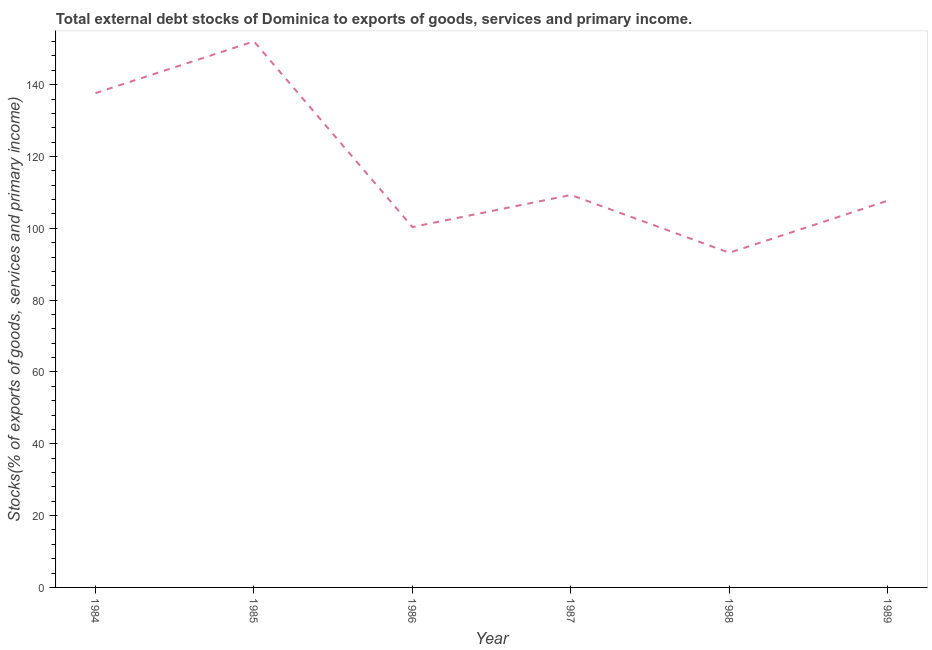What is the external debt stocks in 1989?
Ensure brevity in your answer.  107.7. Across all years, what is the maximum external debt stocks?
Keep it short and to the point. 152.04. Across all years, what is the minimum external debt stocks?
Provide a succinct answer. 93.19. In which year was the external debt stocks maximum?
Make the answer very short. 1985. What is the sum of the external debt stocks?
Make the answer very short. 700.21. What is the difference between the external debt stocks in 1984 and 1989?
Your response must be concise. 29.94. What is the average external debt stocks per year?
Make the answer very short. 116.7. What is the median external debt stocks?
Provide a short and direct response. 108.49. Do a majority of the years between 1986 and 1985 (inclusive) have external debt stocks greater than 56 %?
Offer a terse response. No. What is the ratio of the external debt stocks in 1984 to that in 1986?
Give a very brief answer. 1.37. What is the difference between the highest and the second highest external debt stocks?
Your answer should be compact. 14.4. Is the sum of the external debt stocks in 1987 and 1988 greater than the maximum external debt stocks across all years?
Make the answer very short. Yes. What is the difference between the highest and the lowest external debt stocks?
Give a very brief answer. 58.86. Does the external debt stocks monotonically increase over the years?
Make the answer very short. No. How many lines are there?
Your answer should be compact. 1. What is the difference between two consecutive major ticks on the Y-axis?
Offer a terse response. 20. Are the values on the major ticks of Y-axis written in scientific E-notation?
Your answer should be compact. No. What is the title of the graph?
Offer a very short reply. Total external debt stocks of Dominica to exports of goods, services and primary income. What is the label or title of the Y-axis?
Provide a short and direct response. Stocks(% of exports of goods, services and primary income). What is the Stocks(% of exports of goods, services and primary income) of 1984?
Provide a short and direct response. 137.64. What is the Stocks(% of exports of goods, services and primary income) of 1985?
Give a very brief answer. 152.04. What is the Stocks(% of exports of goods, services and primary income) of 1986?
Keep it short and to the point. 100.35. What is the Stocks(% of exports of goods, services and primary income) in 1987?
Your answer should be very brief. 109.28. What is the Stocks(% of exports of goods, services and primary income) of 1988?
Provide a short and direct response. 93.19. What is the Stocks(% of exports of goods, services and primary income) in 1989?
Your answer should be very brief. 107.7. What is the difference between the Stocks(% of exports of goods, services and primary income) in 1984 and 1985?
Provide a short and direct response. -14.4. What is the difference between the Stocks(% of exports of goods, services and primary income) in 1984 and 1986?
Provide a short and direct response. 37.29. What is the difference between the Stocks(% of exports of goods, services and primary income) in 1984 and 1987?
Ensure brevity in your answer.  28.36. What is the difference between the Stocks(% of exports of goods, services and primary income) in 1984 and 1988?
Provide a succinct answer. 44.46. What is the difference between the Stocks(% of exports of goods, services and primary income) in 1984 and 1989?
Your answer should be very brief. 29.94. What is the difference between the Stocks(% of exports of goods, services and primary income) in 1985 and 1986?
Make the answer very short. 51.69. What is the difference between the Stocks(% of exports of goods, services and primary income) in 1985 and 1987?
Keep it short and to the point. 42.76. What is the difference between the Stocks(% of exports of goods, services and primary income) in 1985 and 1988?
Give a very brief answer. 58.86. What is the difference between the Stocks(% of exports of goods, services and primary income) in 1985 and 1989?
Ensure brevity in your answer.  44.34. What is the difference between the Stocks(% of exports of goods, services and primary income) in 1986 and 1987?
Offer a terse response. -8.93. What is the difference between the Stocks(% of exports of goods, services and primary income) in 1986 and 1988?
Your answer should be compact. 7.17. What is the difference between the Stocks(% of exports of goods, services and primary income) in 1986 and 1989?
Your answer should be very brief. -7.35. What is the difference between the Stocks(% of exports of goods, services and primary income) in 1987 and 1988?
Ensure brevity in your answer.  16.1. What is the difference between the Stocks(% of exports of goods, services and primary income) in 1987 and 1989?
Provide a short and direct response. 1.58. What is the difference between the Stocks(% of exports of goods, services and primary income) in 1988 and 1989?
Offer a very short reply. -14.52. What is the ratio of the Stocks(% of exports of goods, services and primary income) in 1984 to that in 1985?
Offer a very short reply. 0.91. What is the ratio of the Stocks(% of exports of goods, services and primary income) in 1984 to that in 1986?
Your answer should be compact. 1.37. What is the ratio of the Stocks(% of exports of goods, services and primary income) in 1984 to that in 1987?
Give a very brief answer. 1.26. What is the ratio of the Stocks(% of exports of goods, services and primary income) in 1984 to that in 1988?
Provide a succinct answer. 1.48. What is the ratio of the Stocks(% of exports of goods, services and primary income) in 1984 to that in 1989?
Provide a short and direct response. 1.28. What is the ratio of the Stocks(% of exports of goods, services and primary income) in 1985 to that in 1986?
Your answer should be very brief. 1.51. What is the ratio of the Stocks(% of exports of goods, services and primary income) in 1985 to that in 1987?
Keep it short and to the point. 1.39. What is the ratio of the Stocks(% of exports of goods, services and primary income) in 1985 to that in 1988?
Your response must be concise. 1.63. What is the ratio of the Stocks(% of exports of goods, services and primary income) in 1985 to that in 1989?
Offer a terse response. 1.41. What is the ratio of the Stocks(% of exports of goods, services and primary income) in 1986 to that in 1987?
Your response must be concise. 0.92. What is the ratio of the Stocks(% of exports of goods, services and primary income) in 1986 to that in 1988?
Offer a terse response. 1.08. What is the ratio of the Stocks(% of exports of goods, services and primary income) in 1986 to that in 1989?
Your answer should be very brief. 0.93. What is the ratio of the Stocks(% of exports of goods, services and primary income) in 1987 to that in 1988?
Your answer should be very brief. 1.17. What is the ratio of the Stocks(% of exports of goods, services and primary income) in 1987 to that in 1989?
Make the answer very short. 1.01. What is the ratio of the Stocks(% of exports of goods, services and primary income) in 1988 to that in 1989?
Keep it short and to the point. 0.86. 